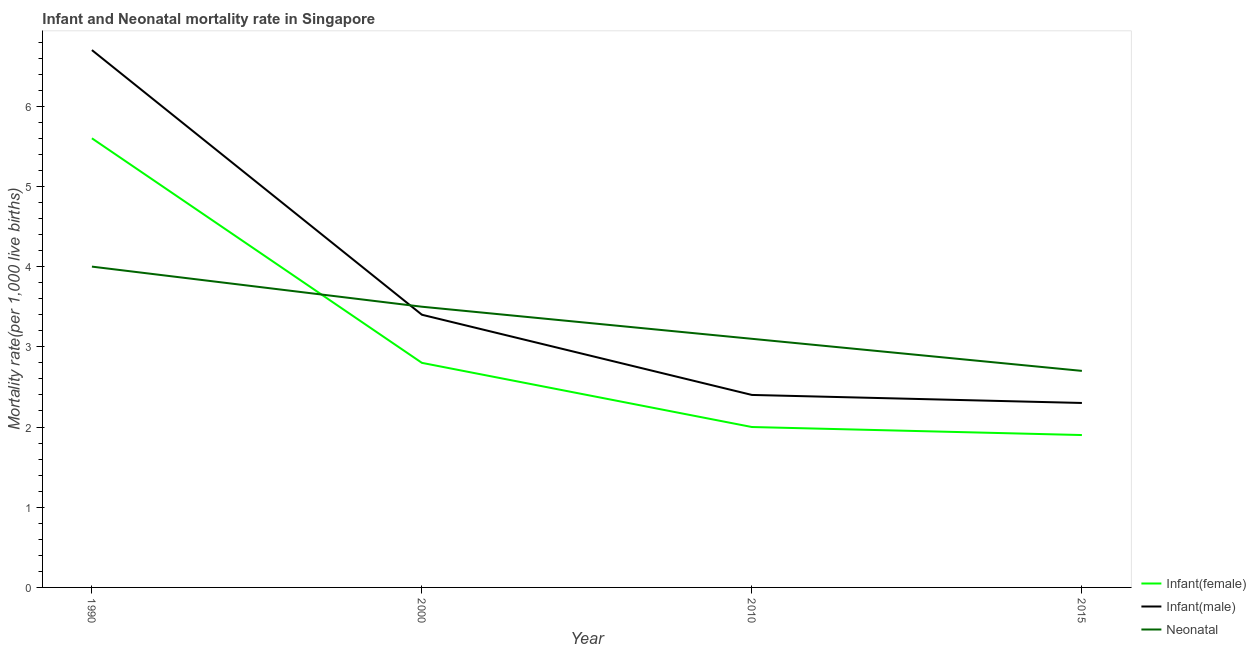How many different coloured lines are there?
Keep it short and to the point. 3. In which year was the neonatal mortality rate maximum?
Offer a terse response. 1990. In which year was the infant mortality rate(male) minimum?
Your answer should be compact. 2015. What is the total infant mortality rate(male) in the graph?
Make the answer very short. 14.8. What is the difference between the infant mortality rate(female) in 2010 and that in 2015?
Make the answer very short. 0.1. What is the difference between the infant mortality rate(female) in 2010 and the neonatal mortality rate in 1990?
Your answer should be compact. -2. What is the average infant mortality rate(female) per year?
Your response must be concise. 3.07. In the year 2015, what is the difference between the infant mortality rate(male) and neonatal mortality rate?
Ensure brevity in your answer.  -0.4. In how many years, is the infant mortality rate(male) greater than 4.8?
Your answer should be compact. 1. What is the ratio of the neonatal mortality rate in 1990 to that in 2015?
Offer a very short reply. 1.48. Is the infant mortality rate(male) in 1990 less than that in 2000?
Offer a terse response. No. Is the difference between the infant mortality rate(male) in 2000 and 2015 greater than the difference between the neonatal mortality rate in 2000 and 2015?
Ensure brevity in your answer.  Yes. What is the difference between the highest and the lowest infant mortality rate(female)?
Offer a terse response. 3.7. Is the sum of the infant mortality rate(female) in 1990 and 2010 greater than the maximum infant mortality rate(male) across all years?
Offer a very short reply. Yes. Is it the case that in every year, the sum of the infant mortality rate(female) and infant mortality rate(male) is greater than the neonatal mortality rate?
Your response must be concise. Yes. Does the neonatal mortality rate monotonically increase over the years?
Offer a very short reply. No. Is the infant mortality rate(female) strictly greater than the infant mortality rate(male) over the years?
Provide a succinct answer. No. Is the infant mortality rate(female) strictly less than the infant mortality rate(male) over the years?
Offer a very short reply. Yes. How many years are there in the graph?
Give a very brief answer. 4. Are the values on the major ticks of Y-axis written in scientific E-notation?
Provide a short and direct response. No. Where does the legend appear in the graph?
Make the answer very short. Bottom right. How many legend labels are there?
Provide a succinct answer. 3. How are the legend labels stacked?
Provide a short and direct response. Vertical. What is the title of the graph?
Offer a very short reply. Infant and Neonatal mortality rate in Singapore. What is the label or title of the X-axis?
Offer a very short reply. Year. What is the label or title of the Y-axis?
Your answer should be very brief. Mortality rate(per 1,0 live births). What is the Mortality rate(per 1,000 live births) in Infant(female) in 1990?
Your response must be concise. 5.6. What is the Mortality rate(per 1,000 live births) in Infant(male) in 1990?
Offer a very short reply. 6.7. What is the Mortality rate(per 1,000 live births) in Infant(female) in 2000?
Your answer should be compact. 2.8. What is the Mortality rate(per 1,000 live births) in Infant(male) in 2000?
Offer a very short reply. 3.4. What is the Mortality rate(per 1,000 live births) in Neonatal  in 2000?
Give a very brief answer. 3.5. What is the Mortality rate(per 1,000 live births) of Infant(female) in 2010?
Offer a very short reply. 2. What is the Mortality rate(per 1,000 live births) in Infant(male) in 2010?
Ensure brevity in your answer.  2.4. What is the Mortality rate(per 1,000 live births) in Neonatal  in 2010?
Make the answer very short. 3.1. What is the Mortality rate(per 1,000 live births) of Infant(female) in 2015?
Keep it short and to the point. 1.9. What is the Mortality rate(per 1,000 live births) of Infant(male) in 2015?
Your answer should be compact. 2.3. What is the Mortality rate(per 1,000 live births) in Neonatal  in 2015?
Provide a short and direct response. 2.7. Across all years, what is the maximum Mortality rate(per 1,000 live births) in Infant(female)?
Your response must be concise. 5.6. Across all years, what is the maximum Mortality rate(per 1,000 live births) of Infant(male)?
Your response must be concise. 6.7. Across all years, what is the minimum Mortality rate(per 1,000 live births) in Infant(male)?
Your answer should be very brief. 2.3. Across all years, what is the minimum Mortality rate(per 1,000 live births) in Neonatal ?
Offer a very short reply. 2.7. What is the total Mortality rate(per 1,000 live births) of Infant(female) in the graph?
Keep it short and to the point. 12.3. What is the difference between the Mortality rate(per 1,000 live births) in Infant(male) in 1990 and that in 2010?
Provide a succinct answer. 4.3. What is the difference between the Mortality rate(per 1,000 live births) of Neonatal  in 1990 and that in 2010?
Keep it short and to the point. 0.9. What is the difference between the Mortality rate(per 1,000 live births) in Infant(female) in 1990 and that in 2015?
Your answer should be very brief. 3.7. What is the difference between the Mortality rate(per 1,000 live births) in Neonatal  in 1990 and that in 2015?
Offer a terse response. 1.3. What is the difference between the Mortality rate(per 1,000 live births) of Infant(female) in 2000 and that in 2010?
Give a very brief answer. 0.8. What is the difference between the Mortality rate(per 1,000 live births) in Infant(male) in 2000 and that in 2010?
Your response must be concise. 1. What is the difference between the Mortality rate(per 1,000 live births) of Infant(male) in 2000 and that in 2015?
Provide a short and direct response. 1.1. What is the difference between the Mortality rate(per 1,000 live births) in Infant(female) in 2010 and that in 2015?
Your response must be concise. 0.1. What is the difference between the Mortality rate(per 1,000 live births) in Infant(male) in 2010 and that in 2015?
Your answer should be compact. 0.1. What is the difference between the Mortality rate(per 1,000 live births) of Neonatal  in 2010 and that in 2015?
Keep it short and to the point. 0.4. What is the difference between the Mortality rate(per 1,000 live births) in Infant(female) in 1990 and the Mortality rate(per 1,000 live births) in Infant(male) in 2010?
Make the answer very short. 3.2. What is the difference between the Mortality rate(per 1,000 live births) in Infant(male) in 1990 and the Mortality rate(per 1,000 live births) in Neonatal  in 2015?
Keep it short and to the point. 4. What is the difference between the Mortality rate(per 1,000 live births) of Infant(female) in 2000 and the Mortality rate(per 1,000 live births) of Infant(male) in 2010?
Make the answer very short. 0.4. What is the difference between the Mortality rate(per 1,000 live births) of Infant(male) in 2000 and the Mortality rate(per 1,000 live births) of Neonatal  in 2010?
Make the answer very short. 0.3. What is the difference between the Mortality rate(per 1,000 live births) in Infant(female) in 2000 and the Mortality rate(per 1,000 live births) in Infant(male) in 2015?
Offer a very short reply. 0.5. What is the difference between the Mortality rate(per 1,000 live births) in Infant(female) in 2010 and the Mortality rate(per 1,000 live births) in Neonatal  in 2015?
Offer a very short reply. -0.7. What is the difference between the Mortality rate(per 1,000 live births) in Infant(male) in 2010 and the Mortality rate(per 1,000 live births) in Neonatal  in 2015?
Your answer should be compact. -0.3. What is the average Mortality rate(per 1,000 live births) of Infant(female) per year?
Your answer should be compact. 3.08. What is the average Mortality rate(per 1,000 live births) of Infant(male) per year?
Your response must be concise. 3.7. What is the average Mortality rate(per 1,000 live births) in Neonatal  per year?
Ensure brevity in your answer.  3.33. In the year 1990, what is the difference between the Mortality rate(per 1,000 live births) in Infant(female) and Mortality rate(per 1,000 live births) in Infant(male)?
Make the answer very short. -1.1. In the year 2000, what is the difference between the Mortality rate(per 1,000 live births) in Infant(female) and Mortality rate(per 1,000 live births) in Infant(male)?
Your answer should be compact. -0.6. In the year 2000, what is the difference between the Mortality rate(per 1,000 live births) of Infant(female) and Mortality rate(per 1,000 live births) of Neonatal ?
Give a very brief answer. -0.7. In the year 2000, what is the difference between the Mortality rate(per 1,000 live births) in Infant(male) and Mortality rate(per 1,000 live births) in Neonatal ?
Your response must be concise. -0.1. In the year 2010, what is the difference between the Mortality rate(per 1,000 live births) of Infant(female) and Mortality rate(per 1,000 live births) of Neonatal ?
Your answer should be compact. -1.1. In the year 2015, what is the difference between the Mortality rate(per 1,000 live births) in Infant(female) and Mortality rate(per 1,000 live births) in Infant(male)?
Ensure brevity in your answer.  -0.4. What is the ratio of the Mortality rate(per 1,000 live births) in Infant(female) in 1990 to that in 2000?
Offer a terse response. 2. What is the ratio of the Mortality rate(per 1,000 live births) in Infant(male) in 1990 to that in 2000?
Ensure brevity in your answer.  1.97. What is the ratio of the Mortality rate(per 1,000 live births) in Infant(female) in 1990 to that in 2010?
Offer a terse response. 2.8. What is the ratio of the Mortality rate(per 1,000 live births) of Infant(male) in 1990 to that in 2010?
Make the answer very short. 2.79. What is the ratio of the Mortality rate(per 1,000 live births) in Neonatal  in 1990 to that in 2010?
Provide a succinct answer. 1.29. What is the ratio of the Mortality rate(per 1,000 live births) in Infant(female) in 1990 to that in 2015?
Keep it short and to the point. 2.95. What is the ratio of the Mortality rate(per 1,000 live births) of Infant(male) in 1990 to that in 2015?
Make the answer very short. 2.91. What is the ratio of the Mortality rate(per 1,000 live births) in Neonatal  in 1990 to that in 2015?
Make the answer very short. 1.48. What is the ratio of the Mortality rate(per 1,000 live births) of Infant(female) in 2000 to that in 2010?
Make the answer very short. 1.4. What is the ratio of the Mortality rate(per 1,000 live births) of Infant(male) in 2000 to that in 2010?
Make the answer very short. 1.42. What is the ratio of the Mortality rate(per 1,000 live births) of Neonatal  in 2000 to that in 2010?
Your answer should be very brief. 1.13. What is the ratio of the Mortality rate(per 1,000 live births) in Infant(female) in 2000 to that in 2015?
Make the answer very short. 1.47. What is the ratio of the Mortality rate(per 1,000 live births) in Infant(male) in 2000 to that in 2015?
Give a very brief answer. 1.48. What is the ratio of the Mortality rate(per 1,000 live births) of Neonatal  in 2000 to that in 2015?
Provide a short and direct response. 1.3. What is the ratio of the Mortality rate(per 1,000 live births) of Infant(female) in 2010 to that in 2015?
Offer a very short reply. 1.05. What is the ratio of the Mortality rate(per 1,000 live births) of Infant(male) in 2010 to that in 2015?
Make the answer very short. 1.04. What is the ratio of the Mortality rate(per 1,000 live births) of Neonatal  in 2010 to that in 2015?
Your answer should be compact. 1.15. What is the difference between the highest and the second highest Mortality rate(per 1,000 live births) of Infant(female)?
Keep it short and to the point. 2.8. What is the difference between the highest and the second highest Mortality rate(per 1,000 live births) of Neonatal ?
Ensure brevity in your answer.  0.5. What is the difference between the highest and the lowest Mortality rate(per 1,000 live births) in Infant(female)?
Your answer should be very brief. 3.7. What is the difference between the highest and the lowest Mortality rate(per 1,000 live births) of Neonatal ?
Your answer should be compact. 1.3. 